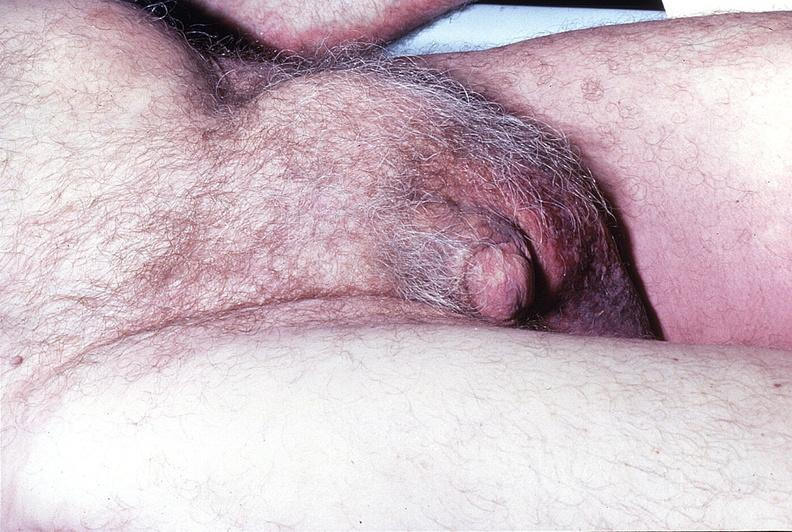what does this image show?
Answer the question using a single word or phrase. Inguinal hernia 